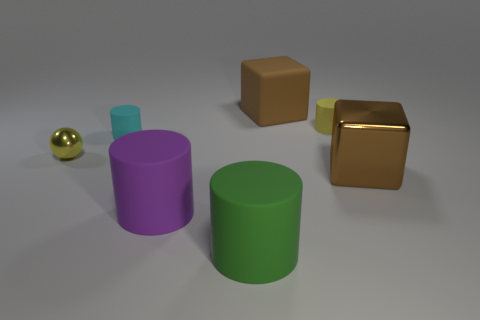What number of small metal balls are on the right side of the tiny yellow thing that is right of the cyan matte cylinder? 0 